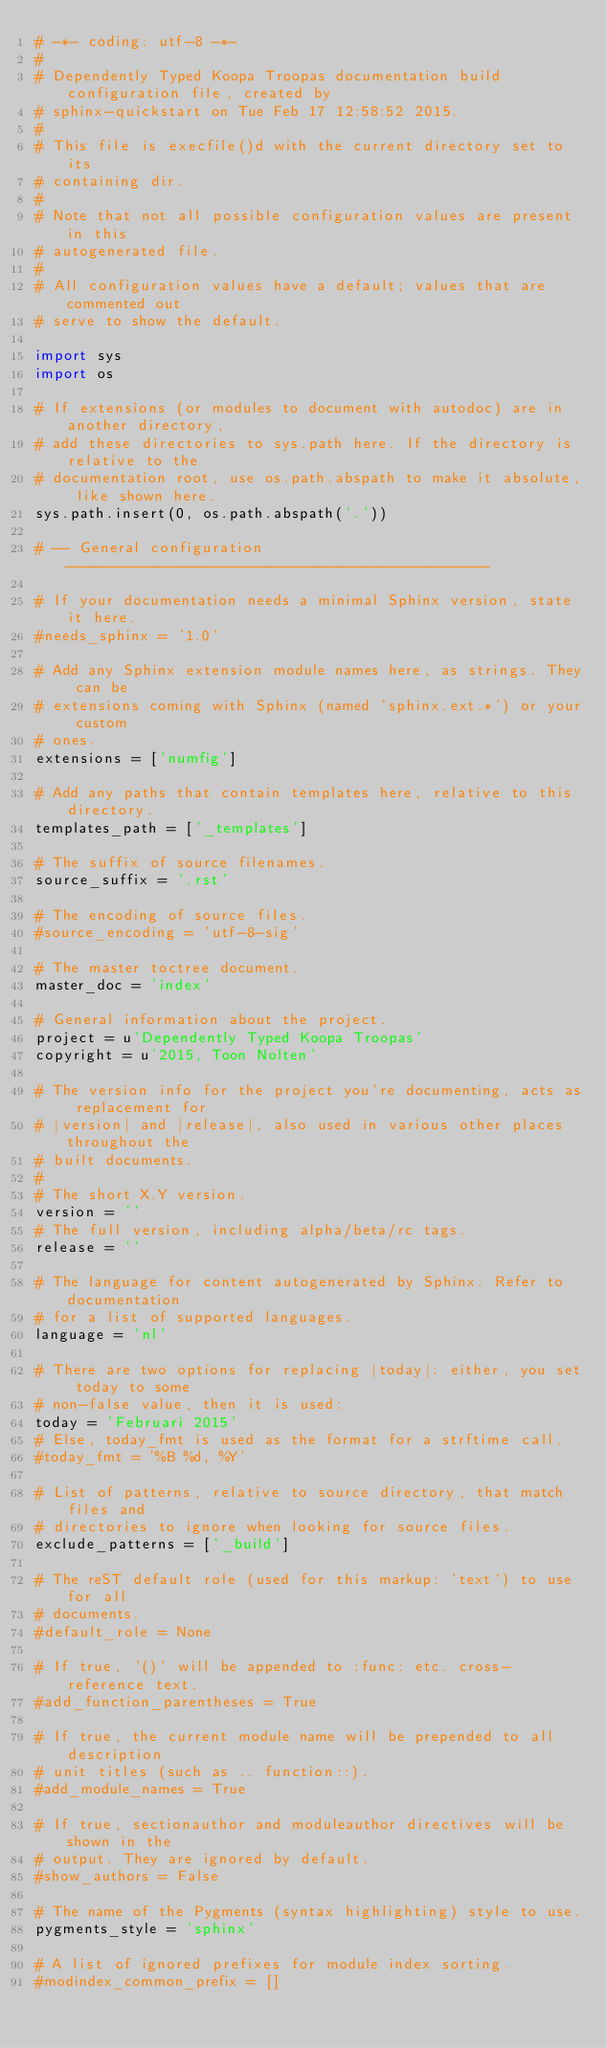<code> <loc_0><loc_0><loc_500><loc_500><_Python_># -*- coding: utf-8 -*-
#
# Dependently Typed Koopa Troopas documentation build configuration file, created by
# sphinx-quickstart on Tue Feb 17 12:58:52 2015.
#
# This file is execfile()d with the current directory set to its
# containing dir.
#
# Note that not all possible configuration values are present in this
# autogenerated file.
#
# All configuration values have a default; values that are commented out
# serve to show the default.

import sys
import os

# If extensions (or modules to document with autodoc) are in another directory,
# add these directories to sys.path here. If the directory is relative to the
# documentation root, use os.path.abspath to make it absolute, like shown here.
sys.path.insert(0, os.path.abspath('.'))

# -- General configuration ------------------------------------------------

# If your documentation needs a minimal Sphinx version, state it here.
#needs_sphinx = '1.0'

# Add any Sphinx extension module names here, as strings. They can be
# extensions coming with Sphinx (named 'sphinx.ext.*') or your custom
# ones.
extensions = ['numfig']

# Add any paths that contain templates here, relative to this directory.
templates_path = ['_templates']

# The suffix of source filenames.
source_suffix = '.rst'

# The encoding of source files.
#source_encoding = 'utf-8-sig'

# The master toctree document.
master_doc = 'index'

# General information about the project.
project = u'Dependently Typed Koopa Troopas'
copyright = u'2015, Toon Nolten'

# The version info for the project you're documenting, acts as replacement for
# |version| and |release|, also used in various other places throughout the
# built documents.
#
# The short X.Y version.
version = ''
# The full version, including alpha/beta/rc tags.
release = ''

# The language for content autogenerated by Sphinx. Refer to documentation
# for a list of supported languages.
language = 'nl'

# There are two options for replacing |today|: either, you set today to some
# non-false value, then it is used:
today = 'Februari 2015'
# Else, today_fmt is used as the format for a strftime call.
#today_fmt = '%B %d, %Y'

# List of patterns, relative to source directory, that match files and
# directories to ignore when looking for source files.
exclude_patterns = ['_build']

# The reST default role (used for this markup: `text`) to use for all
# documents.
#default_role = None

# If true, '()' will be appended to :func: etc. cross-reference text.
#add_function_parentheses = True

# If true, the current module name will be prepended to all description
# unit titles (such as .. function::).
#add_module_names = True

# If true, sectionauthor and moduleauthor directives will be shown in the
# output. They are ignored by default.
#show_authors = False

# The name of the Pygments (syntax highlighting) style to use.
pygments_style = 'sphinx'

# A list of ignored prefixes for module index sorting.
#modindex_common_prefix = []
</code> 